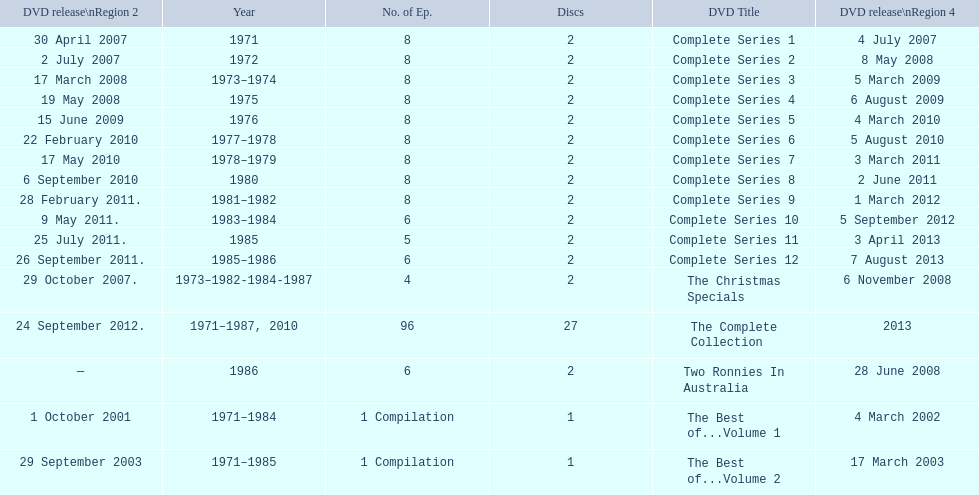The television show "the two ronnies" ran for a total of how many seasons? 12. 